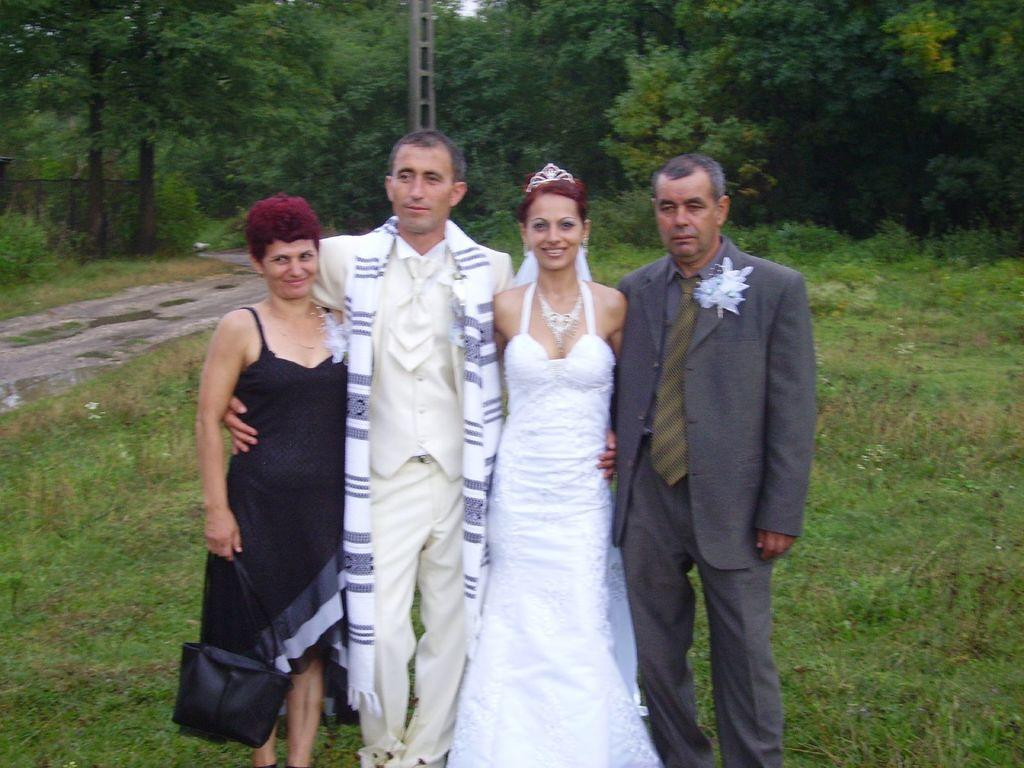How many men are in the image? There are two men in the image. What are the men wearing? The men are wearing suits. How many women are in the image? There are two women in the image. What is the setting of the image? The people are standing on grassland. What can be seen in the background of the image? There are trees visible on the grassland in the background. What type of mint is growing on the grassland in the image? There is no mint visible in the image; it only shows people standing on grassland with trees in the background. 